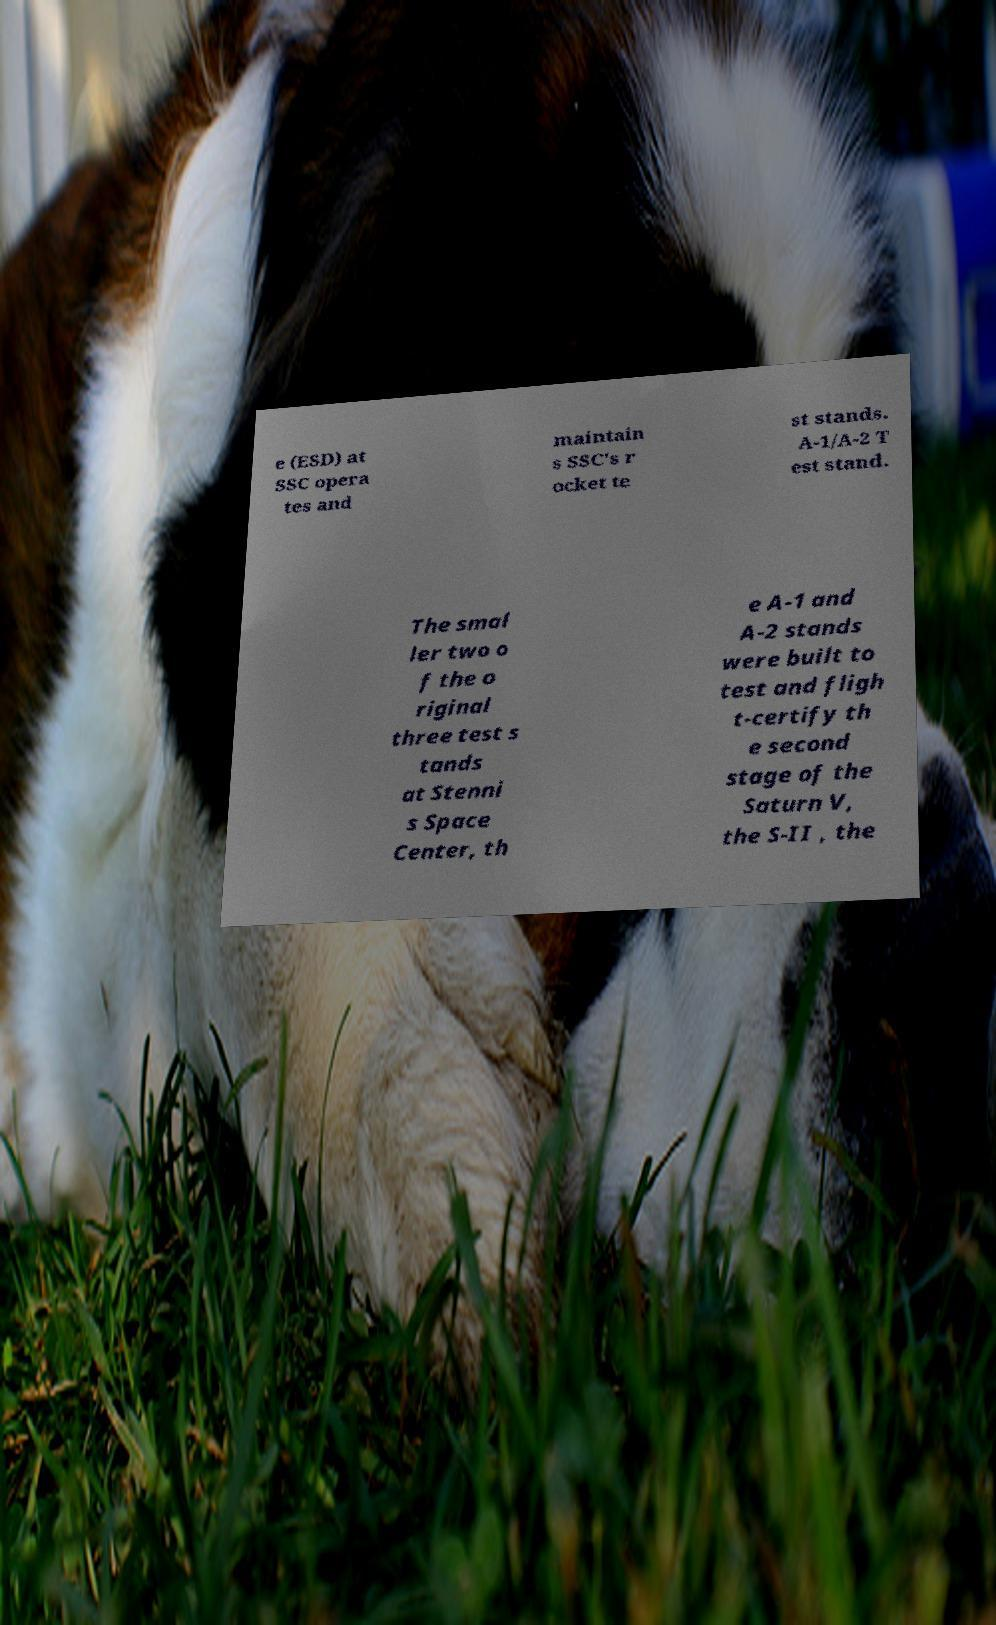For documentation purposes, I need the text within this image transcribed. Could you provide that? e (ESD) at SSC opera tes and maintain s SSC's r ocket te st stands. A-1/A-2 T est stand. The smal ler two o f the o riginal three test s tands at Stenni s Space Center, th e A-1 and A-2 stands were built to test and fligh t-certify th e second stage of the Saturn V, the S-II , the 